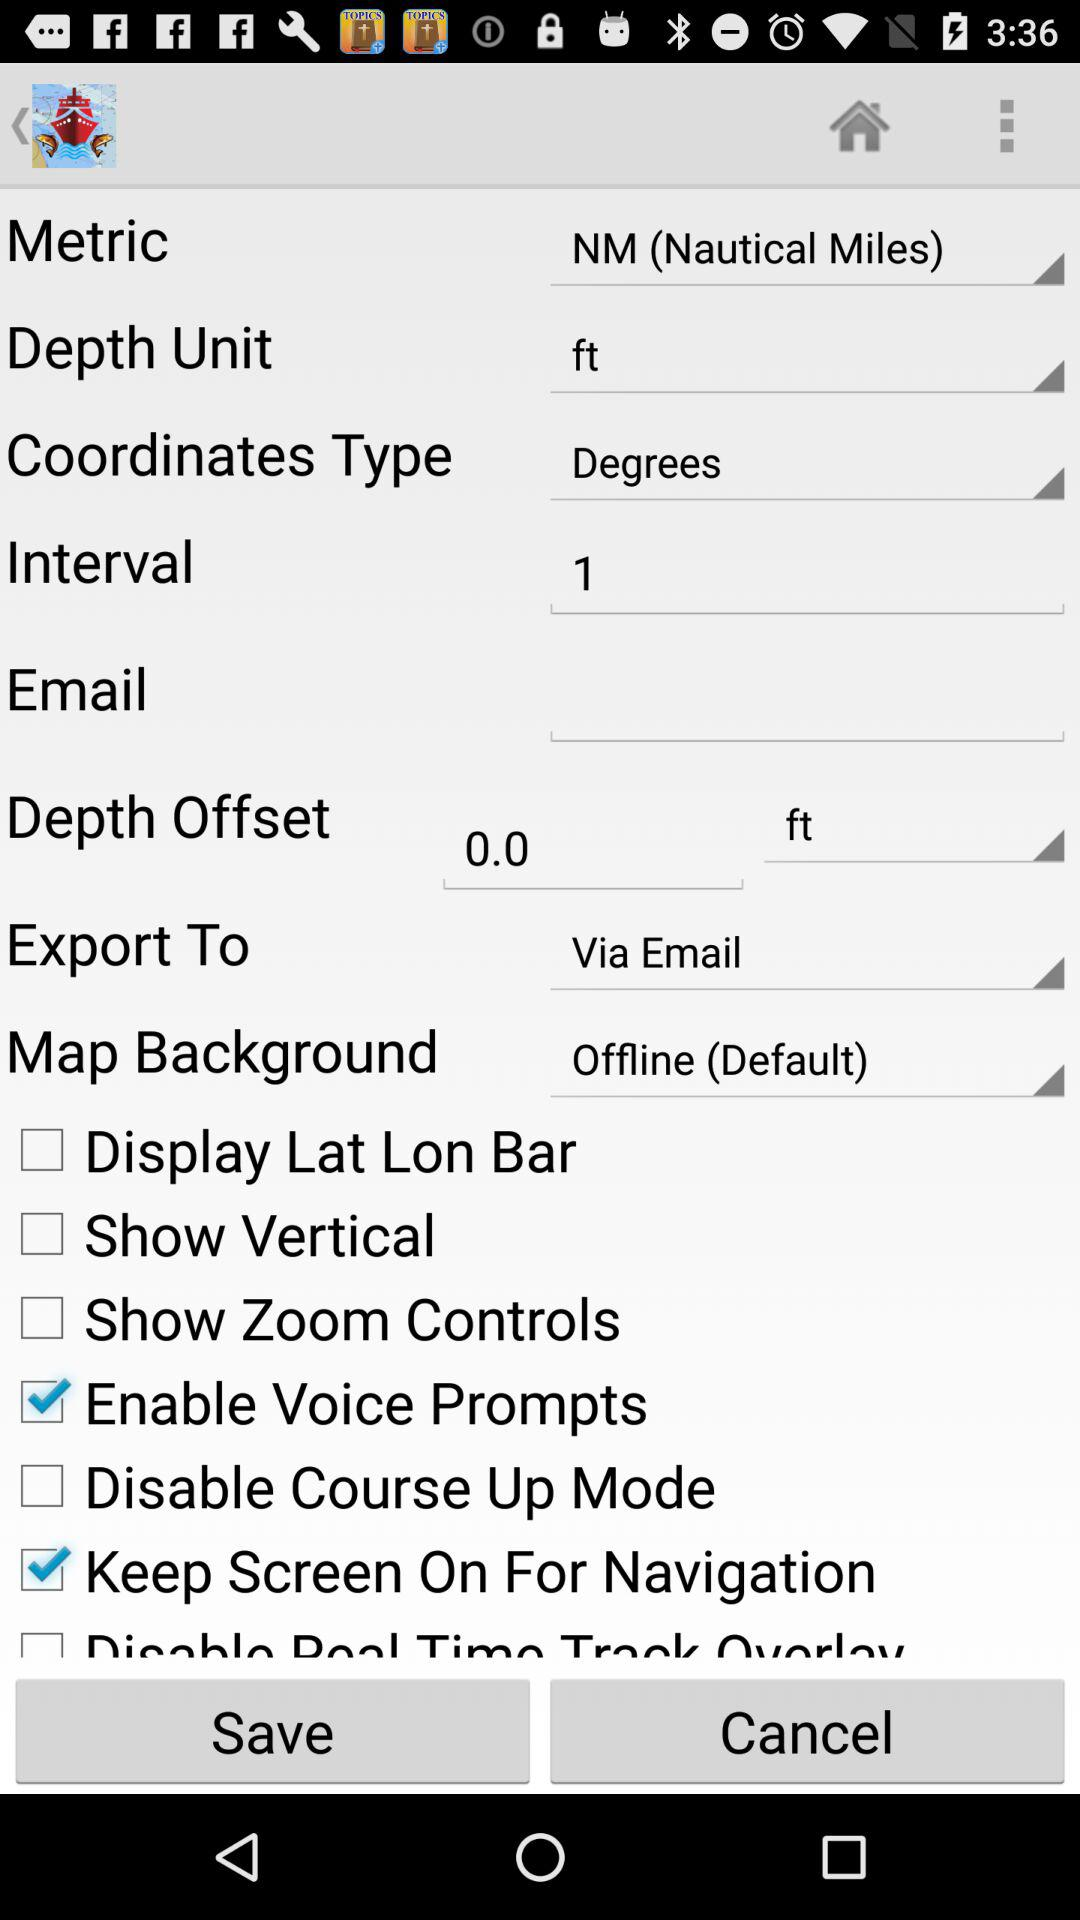What is "Coordinates Type"? "Coordinates Type" is "Degrees". 